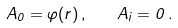<formula> <loc_0><loc_0><loc_500><loc_500>A _ { 0 } = \varphi ( r ) \, , \quad A _ { i } = 0 \, .</formula> 